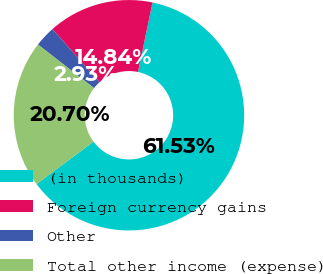Convert chart. <chart><loc_0><loc_0><loc_500><loc_500><pie_chart><fcel>(in thousands)<fcel>Foreign currency gains<fcel>Other<fcel>Total other income (expense)<nl><fcel>61.53%<fcel>14.84%<fcel>2.93%<fcel>20.7%<nl></chart> 